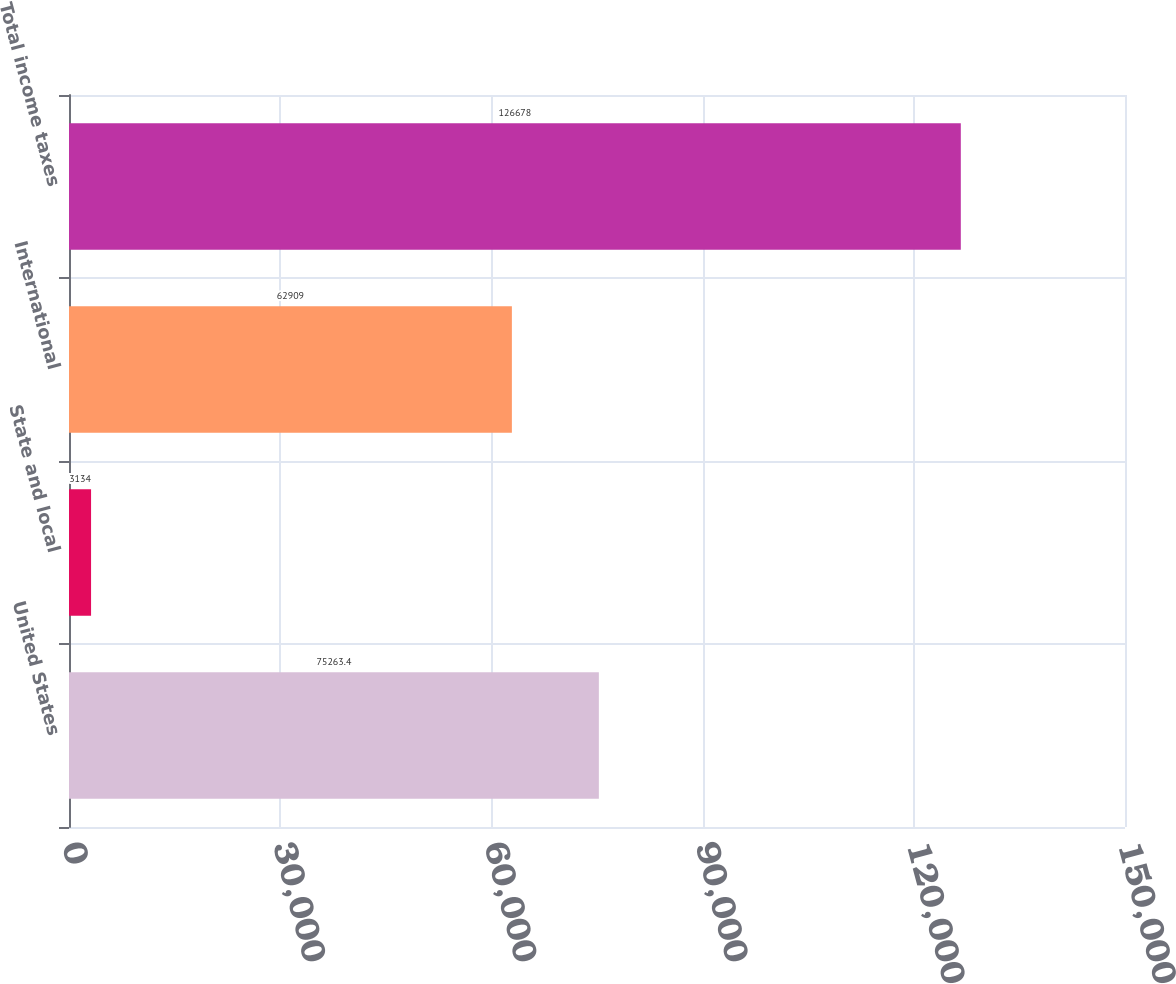<chart> <loc_0><loc_0><loc_500><loc_500><bar_chart><fcel>United States<fcel>State and local<fcel>International<fcel>Total income taxes<nl><fcel>75263.4<fcel>3134<fcel>62909<fcel>126678<nl></chart> 